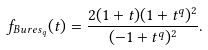<formula> <loc_0><loc_0><loc_500><loc_500>f _ { B u r e s _ { q } } ( t ) = \frac { 2 ( 1 + t ) ( 1 + t ^ { q } ) ^ { 2 } } { ( - 1 + t ^ { q } ) ^ { 2 } } .</formula> 